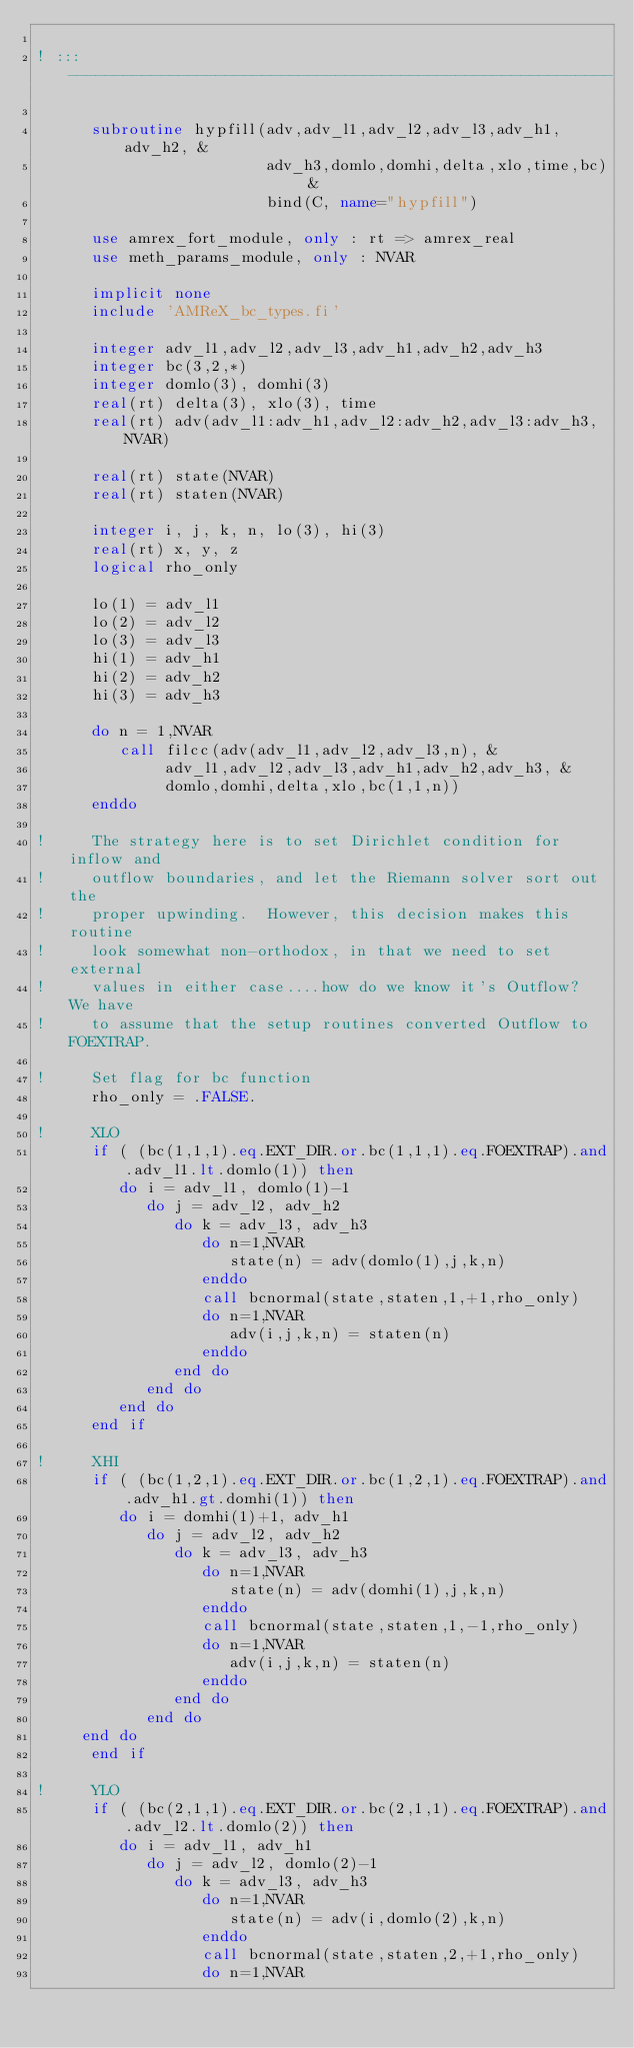Convert code to text. <code><loc_0><loc_0><loc_500><loc_500><_FORTRAN_>
! ::: -----------------------------------------------------------

      subroutine hypfill(adv,adv_l1,adv_l2,adv_l3,adv_h1,adv_h2, &
                         adv_h3,domlo,domhi,delta,xlo,time,bc) &
                         bind(C, name="hypfill")

      use amrex_fort_module, only : rt => amrex_real
      use meth_params_module, only : NVAR

      implicit none
      include 'AMReX_bc_types.fi'

      integer adv_l1,adv_l2,adv_l3,adv_h1,adv_h2,adv_h3
      integer bc(3,2,*)
      integer domlo(3), domhi(3)
      real(rt) delta(3), xlo(3), time
      real(rt) adv(adv_l1:adv_h1,adv_l2:adv_h2,adv_l3:adv_h3,NVAR)

      real(rt) state(NVAR)
      real(rt) staten(NVAR)

      integer i, j, k, n, lo(3), hi(3)
      real(rt) x, y, z
      logical rho_only

      lo(1) = adv_l1
      lo(2) = adv_l2
      lo(3) = adv_l3
      hi(1) = adv_h1
      hi(2) = adv_h2
      hi(3) = adv_h3

      do n = 1,NVAR
         call filcc(adv(adv_l1,adv_l2,adv_l3,n), &
              adv_l1,adv_l2,adv_l3,adv_h1,adv_h2,adv_h3, &
              domlo,domhi,delta,xlo,bc(1,1,n))
      enddo

!     The strategy here is to set Dirichlet condition for inflow and
!     outflow boundaries, and let the Riemann solver sort out the
!     proper upwinding.  However, this decision makes this routine
!     look somewhat non-orthodox, in that we need to set external
!     values in either case....how do we know it's Outflow?  We have
!     to assume that the setup routines converted Outflow to FOEXTRAP.

!     Set flag for bc function
      rho_only = .FALSE.

!     XLO
      if ( (bc(1,1,1).eq.EXT_DIR.or.bc(1,1,1).eq.FOEXTRAP).and.adv_l1.lt.domlo(1)) then
         do i = adv_l1, domlo(1)-1
            do j = adv_l2, adv_h2
               do k = adv_l3, adv_h3
                  do n=1,NVAR
                     state(n) = adv(domlo(1),j,k,n)
                  enddo
                  call bcnormal(state,staten,1,+1,rho_only)
                  do n=1,NVAR
                     adv(i,j,k,n) = staten(n)
                  enddo
               end do
            end do
         end do
      end if            

!     XHI
      if ( (bc(1,2,1).eq.EXT_DIR.or.bc(1,2,1).eq.FOEXTRAP).and.adv_h1.gt.domhi(1)) then
         do i = domhi(1)+1, adv_h1
            do j = adv_l2, adv_h2
               do k = adv_l3, adv_h3
                  do n=1,NVAR
                     state(n) = adv(domhi(1),j,k,n)
                  enddo
                  call bcnormal(state,staten,1,-1,rho_only)
                  do n=1,NVAR
                     adv(i,j,k,n) = staten(n)
                  enddo
               end do
            end do
	 end do
      end if            

!     YLO
      if ( (bc(2,1,1).eq.EXT_DIR.or.bc(2,1,1).eq.FOEXTRAP).and.adv_l2.lt.domlo(2)) then
         do i = adv_l1, adv_h1
            do j = adv_l2, domlo(2)-1
               do k = adv_l3, adv_h3
                  do n=1,NVAR
                     state(n) = adv(i,domlo(2),k,n)
                  enddo
                  call bcnormal(state,staten,2,+1,rho_only)
                  do n=1,NVAR</code> 